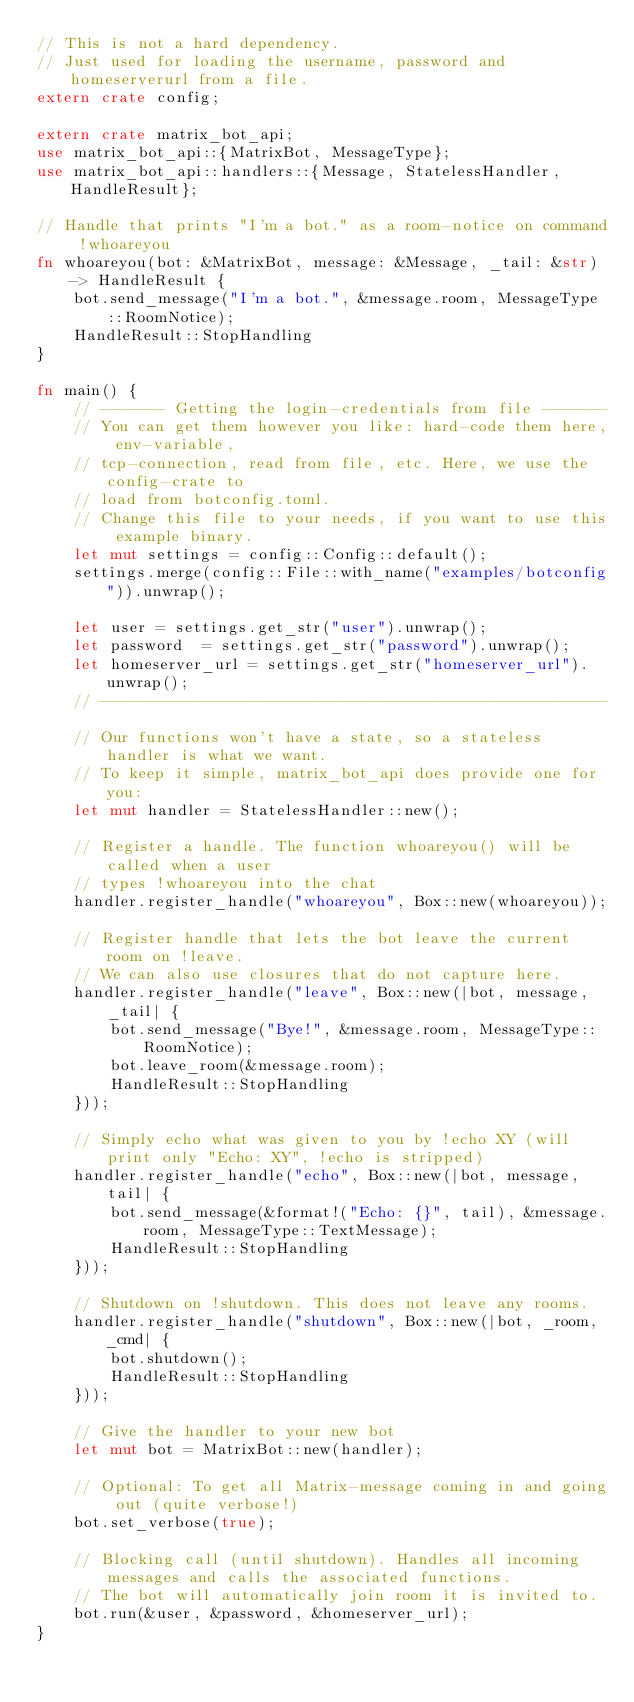<code> <loc_0><loc_0><loc_500><loc_500><_Rust_>// This is not a hard dependency.
// Just used for loading the username, password and homeserverurl from a file.
extern crate config;

extern crate matrix_bot_api;
use matrix_bot_api::{MatrixBot, MessageType};
use matrix_bot_api::handlers::{Message, StatelessHandler, HandleResult};

// Handle that prints "I'm a bot." as a room-notice on command !whoareyou
fn whoareyou(bot: &MatrixBot, message: &Message, _tail: &str) -> HandleResult {
    bot.send_message("I'm a bot.", &message.room, MessageType::RoomNotice);
    HandleResult::StopHandling
}

fn main() {
    // ------- Getting the login-credentials from file -------
    // You can get them however you like: hard-code them here, env-variable,
    // tcp-connection, read from file, etc. Here, we use the config-crate to
    // load from botconfig.toml.
    // Change this file to your needs, if you want to use this example binary.
    let mut settings = config::Config::default();
    settings.merge(config::File::with_name("examples/botconfig")).unwrap();

    let user = settings.get_str("user").unwrap();
    let password  = settings.get_str("password").unwrap();
    let homeserver_url = settings.get_str("homeserver_url").unwrap();
    // -------------------------------------------------------

    // Our functions won't have a state, so a stateless handler is what we want.
    // To keep it simple, matrix_bot_api does provide one for you:
    let mut handler = StatelessHandler::new();

    // Register a handle. The function whoareyou() will be called when a user
    // types !whoareyou into the chat
    handler.register_handle("whoareyou", Box::new(whoareyou));

    // Register handle that lets the bot leave the current room on !leave.
    // We can also use closures that do not capture here.
    handler.register_handle("leave", Box::new(|bot, message, _tail| {
        bot.send_message("Bye!", &message.room, MessageType::RoomNotice);
        bot.leave_room(&message.room);
        HandleResult::StopHandling
    }));

    // Simply echo what was given to you by !echo XY (will print only "Echo: XY", !echo is stripped)
    handler.register_handle("echo", Box::new(|bot, message, tail| {
        bot.send_message(&format!("Echo: {}", tail), &message.room, MessageType::TextMessage);
        HandleResult::StopHandling
    }));

    // Shutdown on !shutdown. This does not leave any rooms.
    handler.register_handle("shutdown", Box::new(|bot, _room, _cmd| {
        bot.shutdown();
        HandleResult::StopHandling
    }));

    // Give the handler to your new bot
    let mut bot = MatrixBot::new(handler);

    // Optional: To get all Matrix-message coming in and going out (quite verbose!)
    bot.set_verbose(true);

    // Blocking call (until shutdown). Handles all incoming messages and calls the associated functions.
    // The bot will automatically join room it is invited to.
    bot.run(&user, &password, &homeserver_url);
}
</code> 